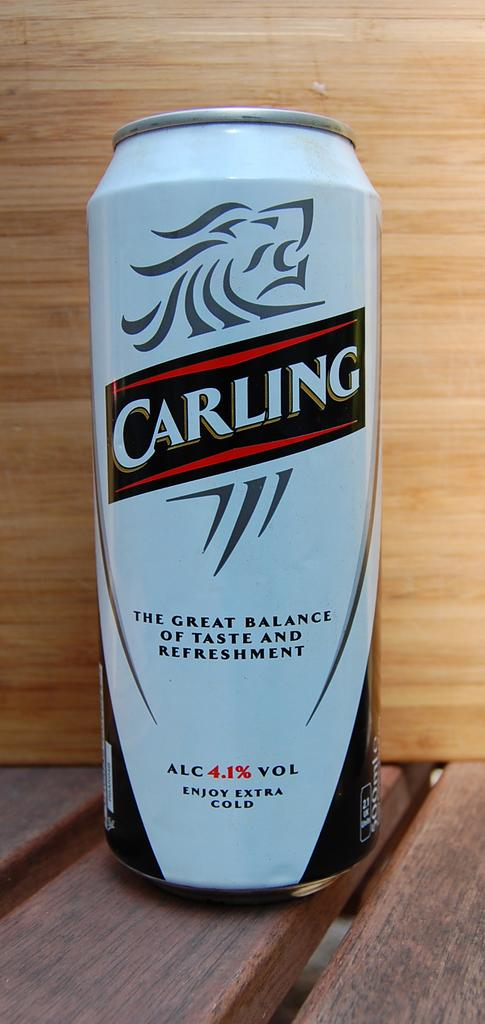<image>
Present a compact description of the photo's key features. White beer can which says CARLIING on it. 